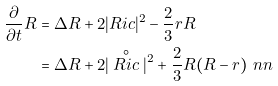Convert formula to latex. <formula><loc_0><loc_0><loc_500><loc_500>\frac { \partial } { \partial t } R & = \Delta R + 2 | R i c | ^ { 2 } - \frac { 2 } { 3 } r R \\ & = \Delta R + 2 | \stackrel { \circ } { R i c } | ^ { 2 } + \frac { 2 } { 3 } R ( R - r ) \ n n</formula> 